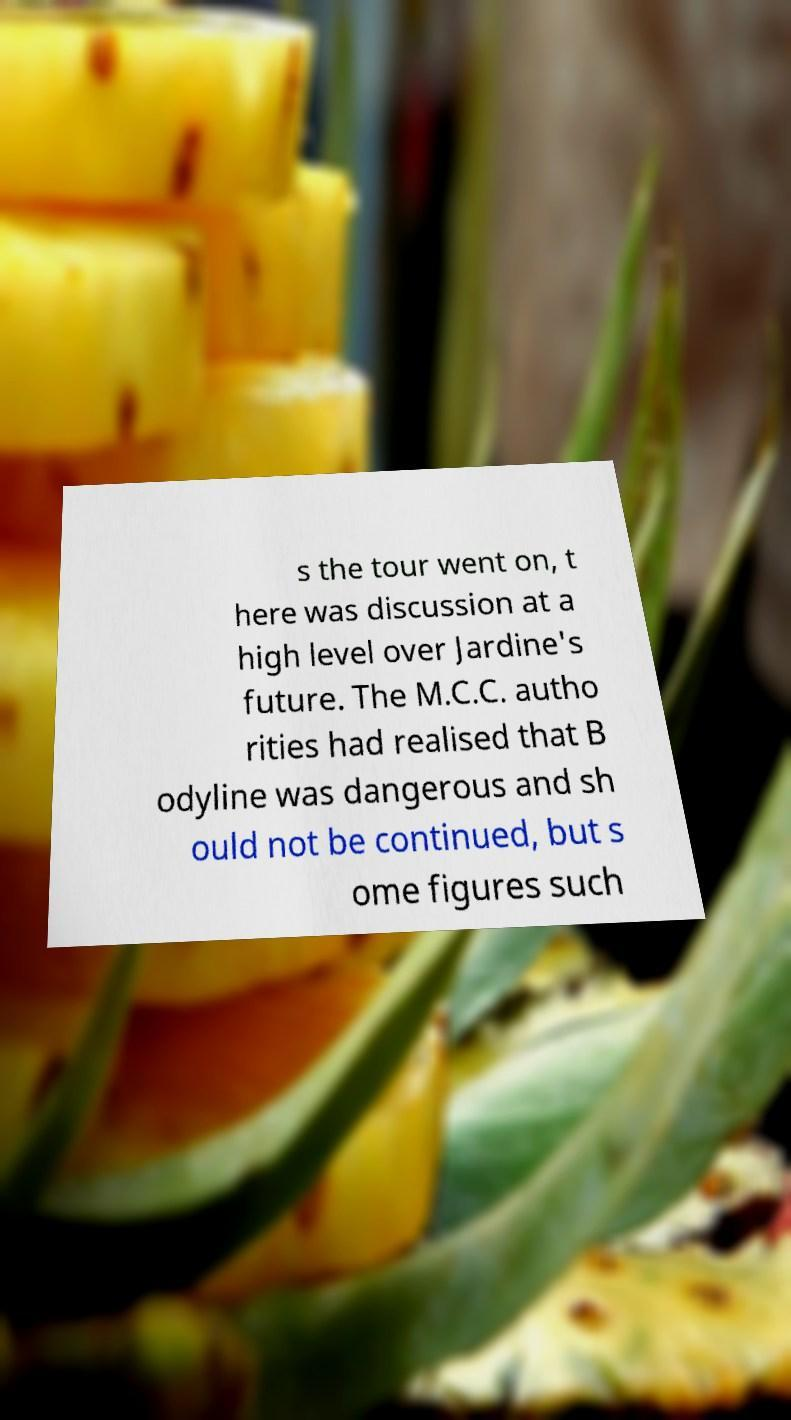I need the written content from this picture converted into text. Can you do that? s the tour went on, t here was discussion at a high level over Jardine's future. The M.C.C. autho rities had realised that B odyline was dangerous and sh ould not be continued, but s ome figures such 